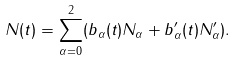<formula> <loc_0><loc_0><loc_500><loc_500>N ( t ) = \sum _ { \alpha = 0 } ^ { 2 } ( b _ { \alpha } ( t ) N _ { \alpha } + b _ { \alpha } ^ { \prime } ( t ) N ^ { \prime } _ { \alpha } ) .</formula> 